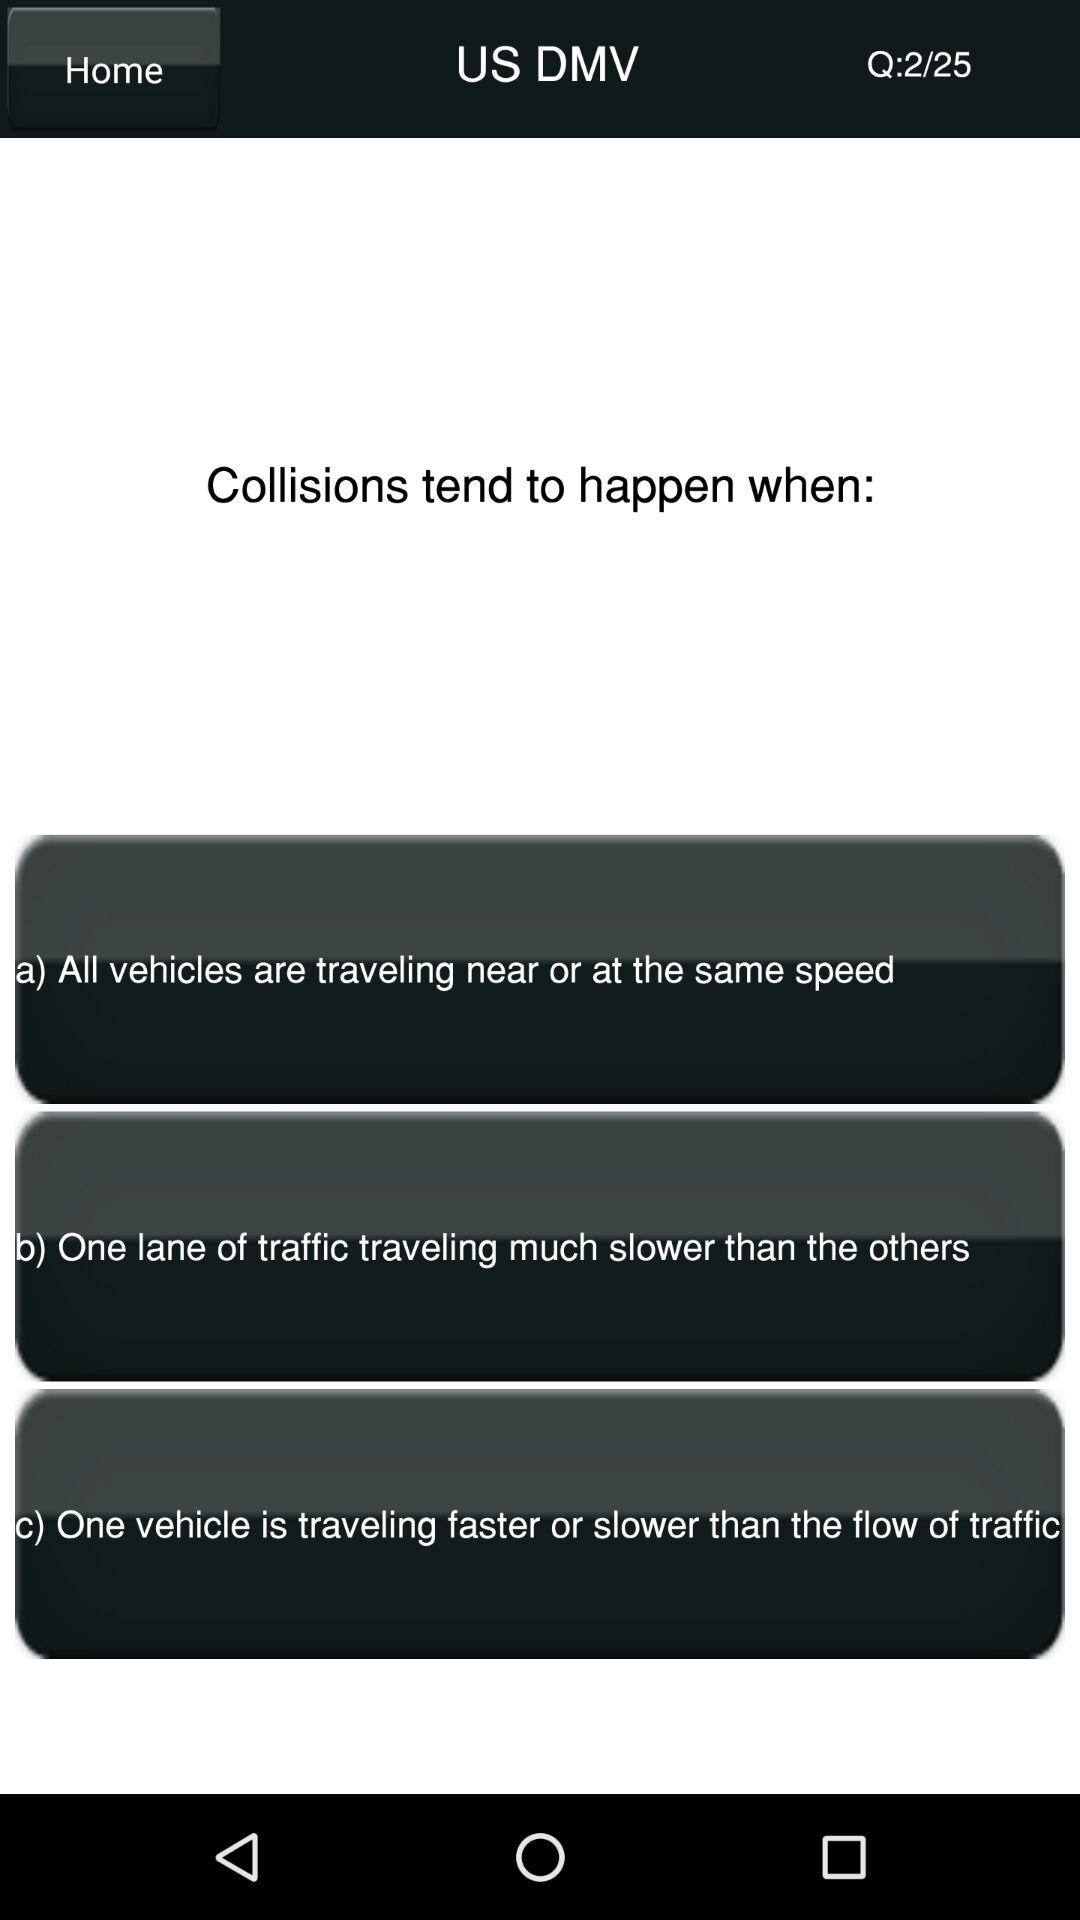How many options are there for the question about collisions?
Answer the question using a single word or phrase. 3 